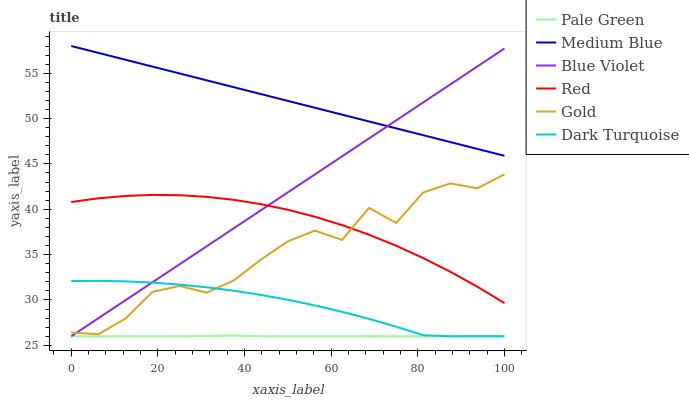Does Dark Turquoise have the minimum area under the curve?
Answer yes or no. No. Does Dark Turquoise have the maximum area under the curve?
Answer yes or no. No. Is Dark Turquoise the smoothest?
Answer yes or no. No. Is Dark Turquoise the roughest?
Answer yes or no. No. Does Medium Blue have the lowest value?
Answer yes or no. No. Does Dark Turquoise have the highest value?
Answer yes or no. No. Is Gold less than Medium Blue?
Answer yes or no. Yes. Is Red greater than Pale Green?
Answer yes or no. Yes. Does Gold intersect Medium Blue?
Answer yes or no. No. 